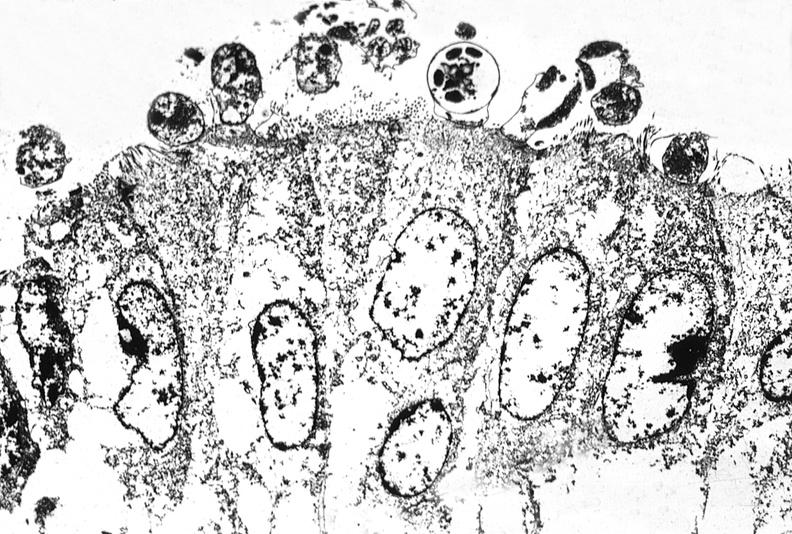does this image show colon biopsy, cryptosporidia?
Answer the question using a single word or phrase. Yes 